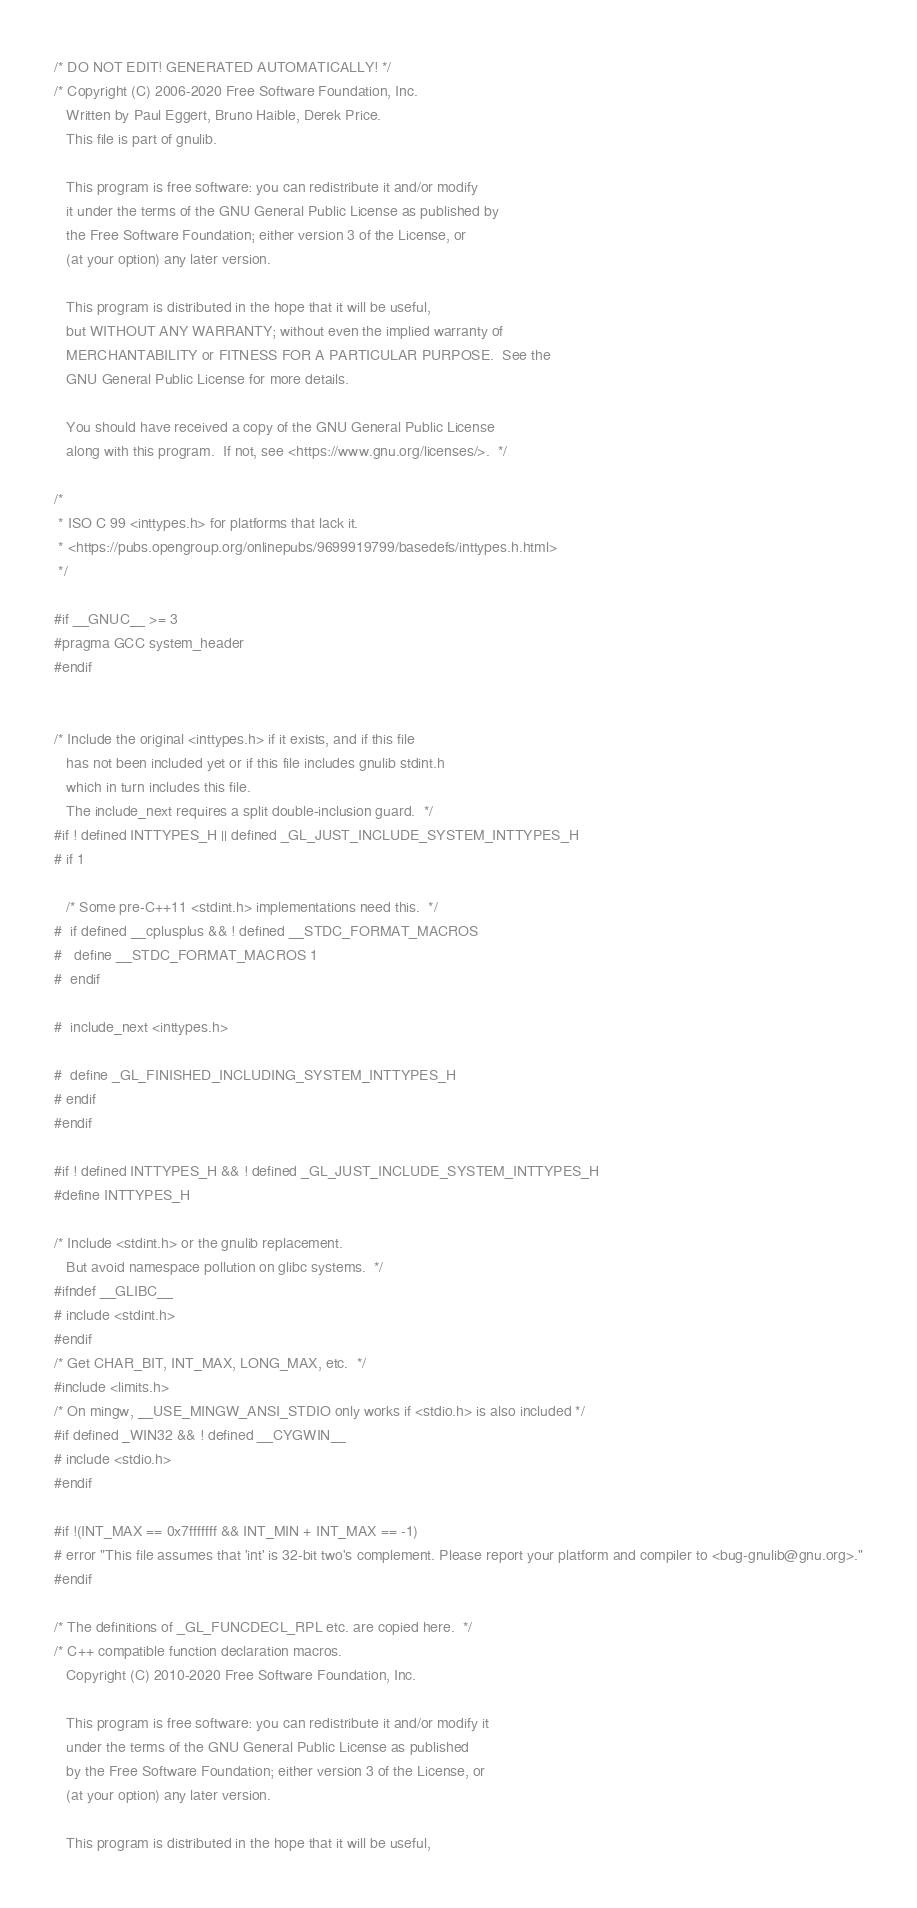<code> <loc_0><loc_0><loc_500><loc_500><_C_>/* DO NOT EDIT! GENERATED AUTOMATICALLY! */
/* Copyright (C) 2006-2020 Free Software Foundation, Inc.
   Written by Paul Eggert, Bruno Haible, Derek Price.
   This file is part of gnulib.

   This program is free software: you can redistribute it and/or modify
   it under the terms of the GNU General Public License as published by
   the Free Software Foundation; either version 3 of the License, or
   (at your option) any later version.

   This program is distributed in the hope that it will be useful,
   but WITHOUT ANY WARRANTY; without even the implied warranty of
   MERCHANTABILITY or FITNESS FOR A PARTICULAR PURPOSE.  See the
   GNU General Public License for more details.

   You should have received a copy of the GNU General Public License
   along with this program.  If not, see <https://www.gnu.org/licenses/>.  */

/*
 * ISO C 99 <inttypes.h> for platforms that lack it.
 * <https://pubs.opengroup.org/onlinepubs/9699919799/basedefs/inttypes.h.html>
 */

#if __GNUC__ >= 3
#pragma GCC system_header
#endif


/* Include the original <inttypes.h> if it exists, and if this file
   has not been included yet or if this file includes gnulib stdint.h
   which in turn includes this file.
   The include_next requires a split double-inclusion guard.  */
#if ! defined INTTYPES_H || defined _GL_JUST_INCLUDE_SYSTEM_INTTYPES_H
# if 1

   /* Some pre-C++11 <stdint.h> implementations need this.  */
#  if defined __cplusplus && ! defined __STDC_FORMAT_MACROS
#   define __STDC_FORMAT_MACROS 1
#  endif

#  include_next <inttypes.h>

#  define _GL_FINISHED_INCLUDING_SYSTEM_INTTYPES_H
# endif
#endif

#if ! defined INTTYPES_H && ! defined _GL_JUST_INCLUDE_SYSTEM_INTTYPES_H
#define INTTYPES_H

/* Include <stdint.h> or the gnulib replacement.
   But avoid namespace pollution on glibc systems.  */
#ifndef __GLIBC__
# include <stdint.h>
#endif
/* Get CHAR_BIT, INT_MAX, LONG_MAX, etc.  */
#include <limits.h>
/* On mingw, __USE_MINGW_ANSI_STDIO only works if <stdio.h> is also included */
#if defined _WIN32 && ! defined __CYGWIN__
# include <stdio.h>
#endif

#if !(INT_MAX == 0x7fffffff && INT_MIN + INT_MAX == -1)
# error "This file assumes that 'int' is 32-bit two's complement. Please report your platform and compiler to <bug-gnulib@gnu.org>."
#endif

/* The definitions of _GL_FUNCDECL_RPL etc. are copied here.  */
/* C++ compatible function declaration macros.
   Copyright (C) 2010-2020 Free Software Foundation, Inc.

   This program is free software: you can redistribute it and/or modify it
   under the terms of the GNU General Public License as published
   by the Free Software Foundation; either version 3 of the License, or
   (at your option) any later version.

   This program is distributed in the hope that it will be useful,</code> 